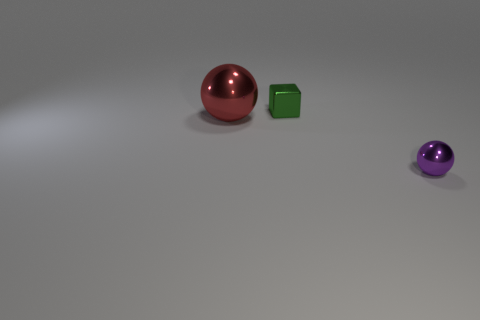What is the shape of the purple thing that is the same size as the green object?
Your answer should be very brief. Sphere. There is a metallic sphere on the left side of the small object that is on the left side of the small purple sphere; what number of purple things are to the right of it?
Give a very brief answer. 1. Is the number of shiny balls to the right of the green block greater than the number of purple spheres that are in front of the purple metallic object?
Keep it short and to the point. Yes. What number of red metal objects have the same shape as the tiny purple thing?
Provide a succinct answer. 1. How many things are either metal cubes behind the large shiny ball or tiny shiny things behind the small purple metallic ball?
Keep it short and to the point. 1. What material is the sphere that is right of the metal sphere that is behind the tiny object that is in front of the block made of?
Give a very brief answer. Metal. Does the tiny metal object that is to the right of the tiny metallic cube have the same color as the small block?
Your response must be concise. No. There is a thing that is in front of the shiny cube and on the left side of the purple shiny sphere; what is its material?
Provide a succinct answer. Metal. Are there any green rubber things that have the same size as the red object?
Make the answer very short. No. How many brown things are there?
Provide a succinct answer. 0. 